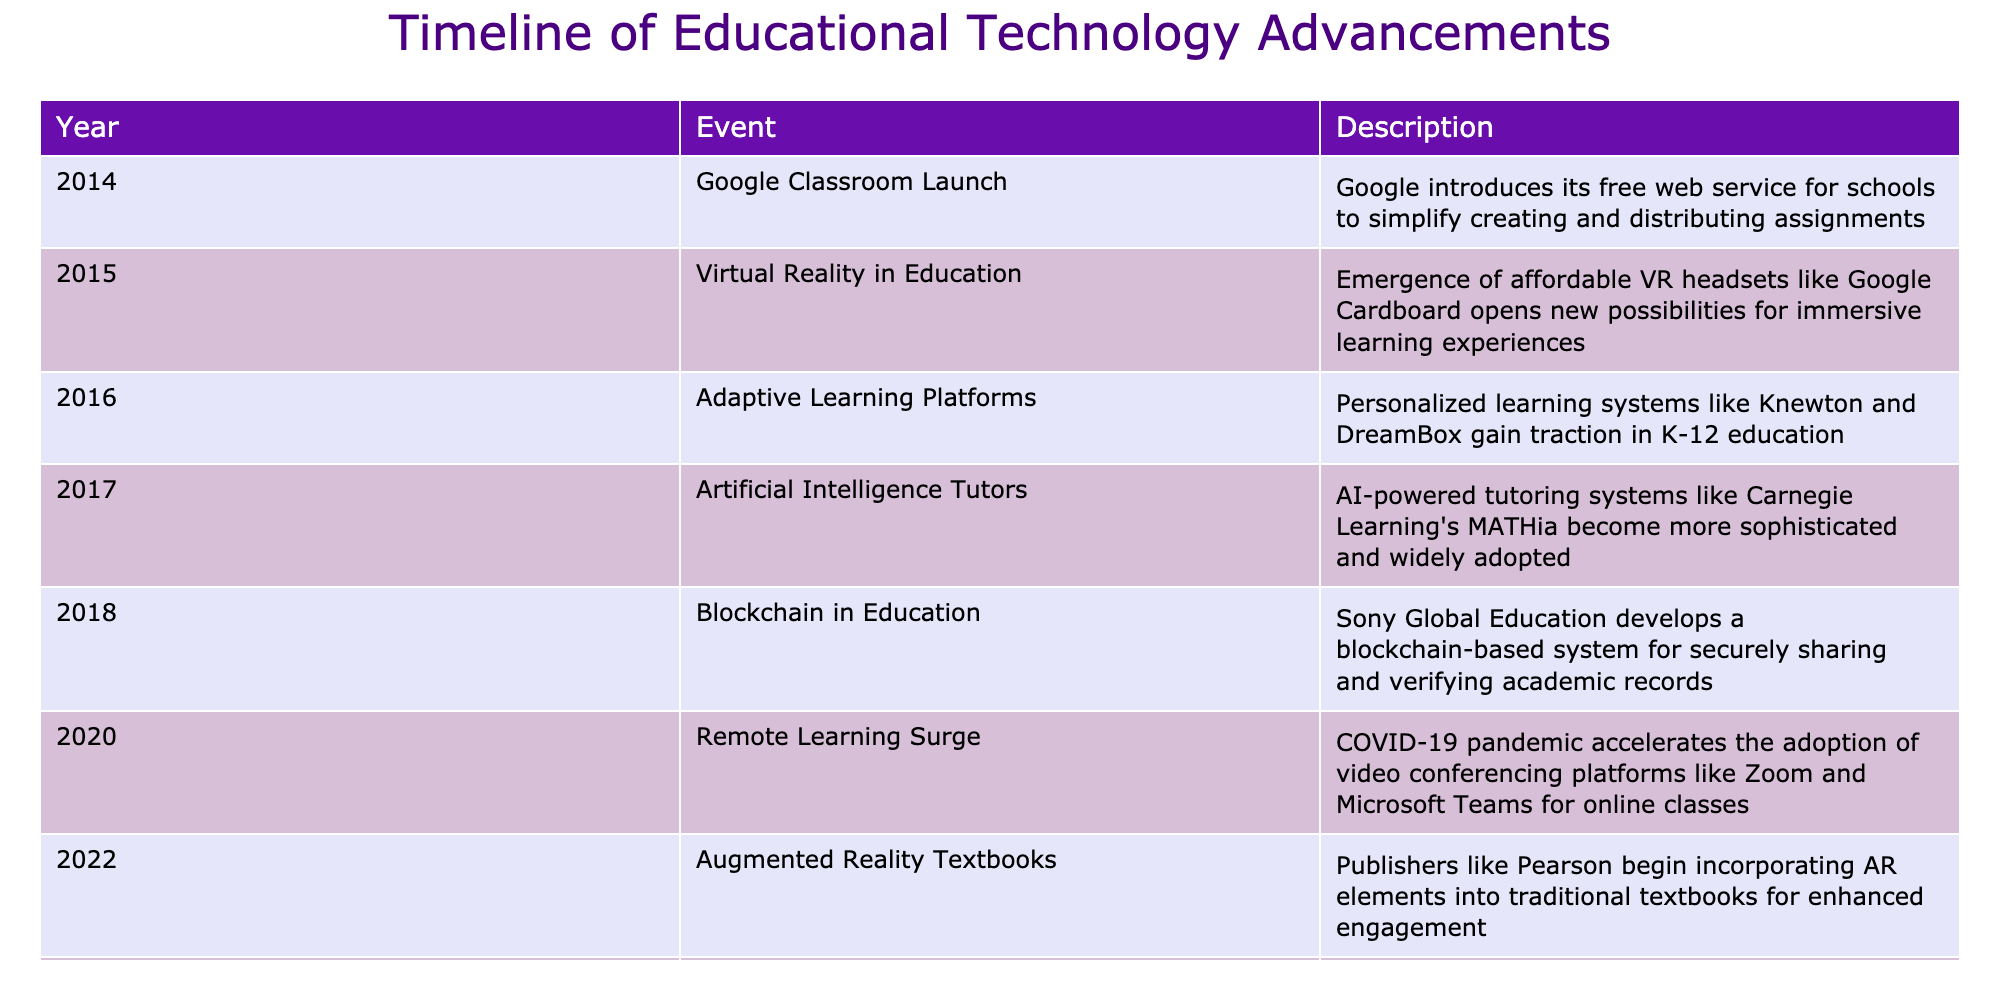What year did Google Classroom launch? The table directly states that Google Classroom was launched in 2014.
Answer: 2014 What event occurred in 2016? According to the table, the event that took place in 2016 is the advent of Adaptive Learning Platforms.
Answer: Adaptive Learning Platforms Which technology emerged in education in 2015? The table mentions that in 2015, Virtual Reality became notable in education due to the availability of affordable VR headsets.
Answer: Virtual Reality Was there an event related to artificial intelligence in education in 2017? The table confirms that in 2017, Artificial Intelligence Tutors became more sophisticated and widely adopted.
Answer: Yes How many advancements occurred in education technology between 2014 and 2022? By counting the events listed between those years, we find 8 different advancements documented in the table from 2014 to 2022.
Answer: 8 What was the first event listed in the timeline? The first event is the launch of Google Classroom, which occurred in 2014.
Answer: Google Classroom Launch Is Blockchain in Education mentioned as a factor in 2021? The table does not list any event related to Blockchain in Education in 2021; it is only noted for 2018.
Answer: No In which year did the use of AI-generated content for education begin? The table specifies that AI-generated content for education started to be utilized in 2023.
Answer: 2023 Which year saw the notable increase in remote learning due to the COVID-19 pandemic? The table highlights that the surge in remote learning took place in 2020 as a result of the pandemic.
Answer: 2020 What is the average year of the listed educational technology events? To find the average, sum the years (2014 + 2015 + 2016 + 2017 + 2018 + 2020 + 2022 + 2023) = 1615. Then divide by the number of events (8). The average is 1615/8 = 201.875, rounded to 2020.
Answer: 2020 